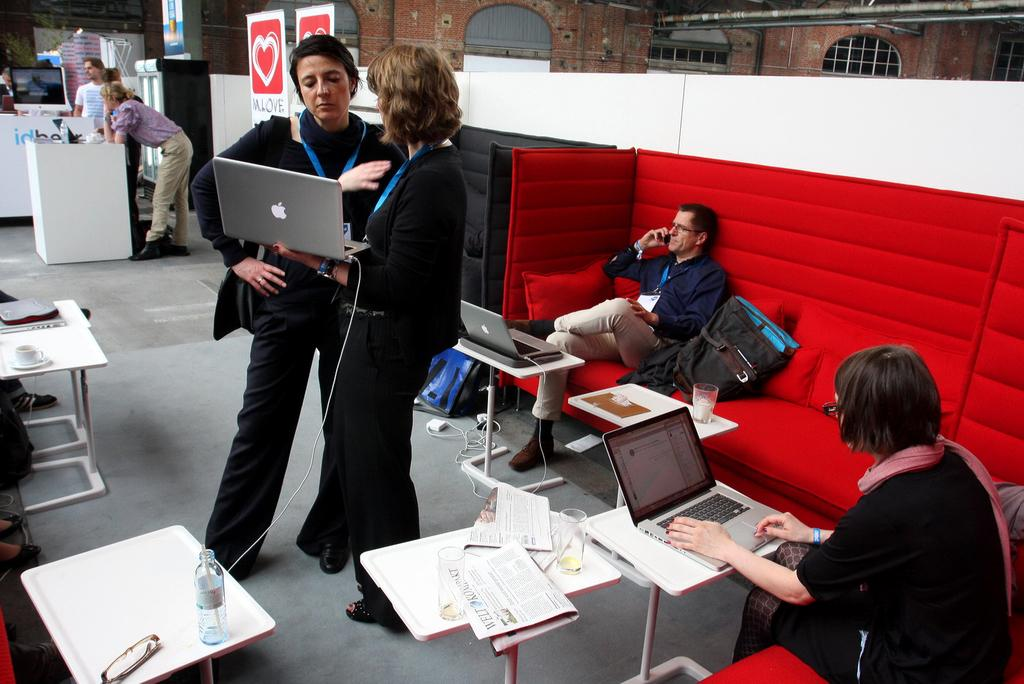What are the people in the image doing? There are people standing in the image, and a woman is holding a laptop in her hand. How many people are seated in the image? There are two people seated in the image. What objects are on the table in the image? There are laptops on the table. What type of bag is the woman carrying in the image? There is no bag visible in the image; the woman is holding a laptop in her hand. Can you tell me how many guns are present in the image? There are no guns present in the image. 